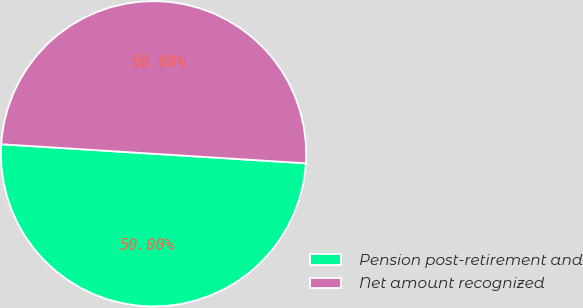Convert chart to OTSL. <chart><loc_0><loc_0><loc_500><loc_500><pie_chart><fcel>Pension post-retirement and<fcel>Net amount recognized<nl><fcel>50.0%<fcel>50.0%<nl></chart> 